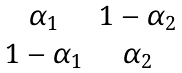<formula> <loc_0><loc_0><loc_500><loc_500>\begin{matrix} \alpha _ { 1 } & 1 - \alpha _ { 2 } \\ 1 - \alpha _ { 1 } & \alpha _ { 2 } \end{matrix}</formula> 